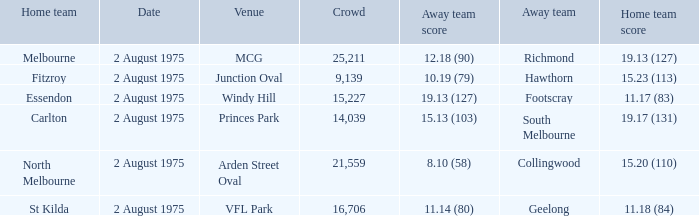What did the away team score when playing North Melbourne? 8.10 (58). 